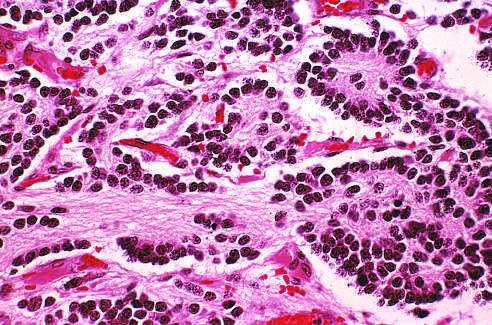what is a homer-wright pseudorosette?
Answer the question using a single word or phrase. Tumor cells arranged concentrically around central core of neuropil 